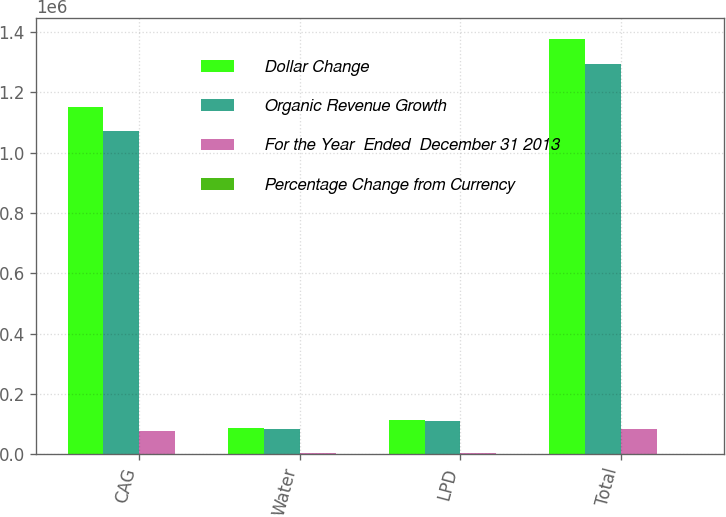<chart> <loc_0><loc_0><loc_500><loc_500><stacked_bar_chart><ecel><fcel>CAG<fcel>Water<fcel>LPD<fcel>Total<nl><fcel>Dollar Change<fcel>1.15017e+06<fcel>87959<fcel>113811<fcel>1.37706e+06<nl><fcel>Organic Revenue Growth<fcel>1.07221e+06<fcel>84680<fcel>111308<fcel>1.29334e+06<nl><fcel>For the Year  Ended  December 31 2013<fcel>77958<fcel>3279<fcel>2503<fcel>83720<nl><fcel>Percentage Change from Currency<fcel>7.3<fcel>3.9<fcel>2.2<fcel>6.5<nl></chart> 